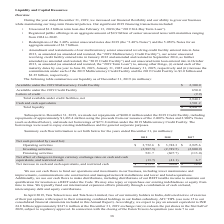According to American Tower Corporation's financial document, What was the net cash provided by (used for) Operating activities in 2019? According to the financial document, $3,752.6 (in millions). The relevant text states: "Operating activities $ 3,752.6 $ 3,748.3 $ 2,925.6..." Also, What was the net cash provided by (used for) investing activities in 2018? According to the financial document, (2,749.5) (in millions). The relevant text states: "Investing activities (3,987.5) (2,749.5) (2,800.9)..." Also, What was the net cash provided by (used for) financing activities in 2017? According to the financial document, (113.0) (in millions). The relevant text states: "Financing activities 521.7 (607.7) (113.0)..." Also, can you calculate: What was the change in the net cash provided by (used for) by operating activities between 2018 and 2019? Based on the calculation: $3,752.6-$3,748.3, the result is 4.3 (in millions). This is based on the information: "Operating activities $ 3,752.6 $ 3,748.3 $ 2,925.6 Operating activities $ 3,752.6 $ 3,748.3 $ 2,925.6..." The key data points involved are: 3,748.3, 3,752.6. Also, can you calculate: What was the change in the net cash provided by (used for) by investing activities between 2017 and 2018? Based on the calculation: -2,749.5-(-2,800.9), the result is 51.4 (in millions). This is based on the information: "Investing activities (3,987.5) (2,749.5) (2,800.9) Investing activities (3,987.5) (2,749.5) (2,800.9)..." The key data points involved are: 2,749.5, 2,800.9. Also, can you calculate: What is the percentage change in the net cash provided by (used for) financing activities between 2017 and 2018? To answer this question, I need to perform calculations using the financial data. The calculation is: (-607.7-(-113.0))/-113.0, which equals 437.79 (percentage). This is based on the information: "Financing activities 521.7 (607.7) (113.0) Financing activities 521.7 (607.7) (113.0)..." The key data points involved are: 113.0, 607.7. 